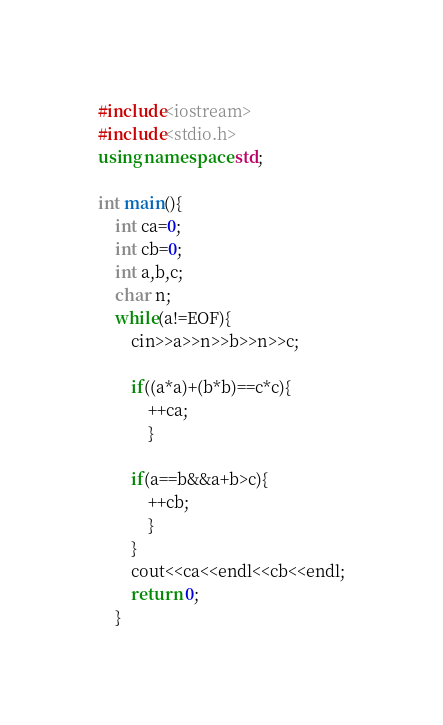<code> <loc_0><loc_0><loc_500><loc_500><_C++_>#include<iostream>
#include<stdio.h>
using namespace std;

int main(){
	int ca=0;
	int cb=0;
	int a,b,c;
	char n;
	while(a!=EOF){
		cin>>a>>n>>b>>n>>c;
		
		if((a*a)+(b*b)==c*c){
			++ca;
			}
			
		if(a==b&&a+b>c){
			++cb;
			}	
		}
		cout<<ca<<endl<<cb<<endl;
		return 0;
	}</code> 